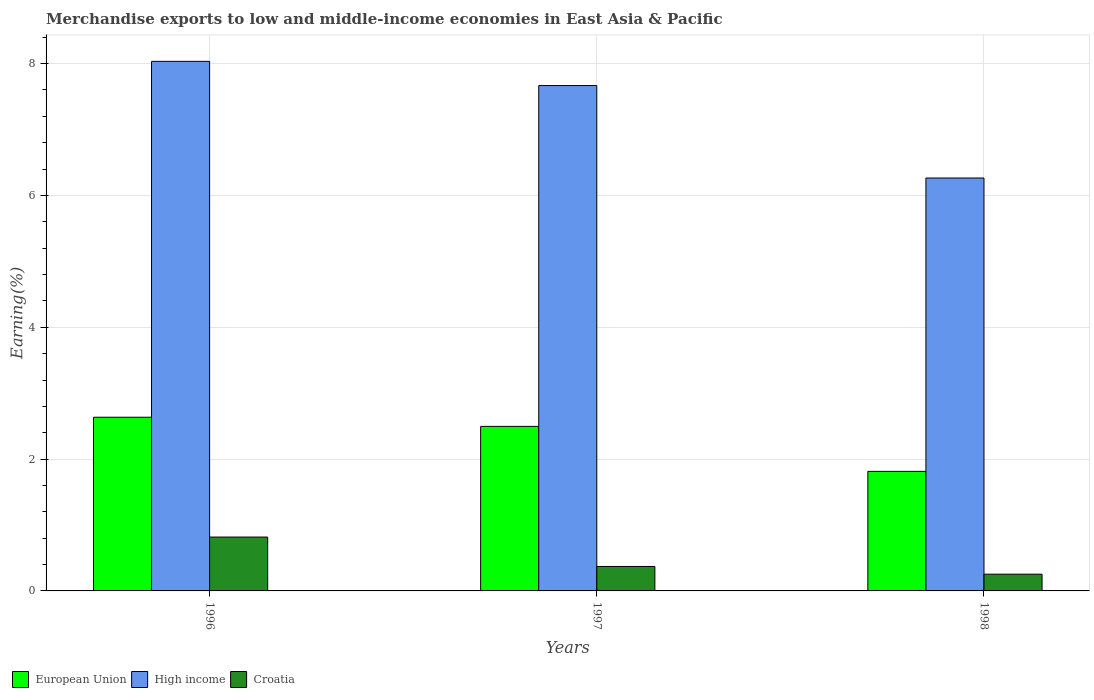How many different coloured bars are there?
Make the answer very short. 3. Are the number of bars on each tick of the X-axis equal?
Provide a short and direct response. Yes. How many bars are there on the 1st tick from the left?
Make the answer very short. 3. How many bars are there on the 3rd tick from the right?
Give a very brief answer. 3. What is the percentage of amount earned from merchandise exports in Croatia in 1996?
Make the answer very short. 0.82. Across all years, what is the maximum percentage of amount earned from merchandise exports in Croatia?
Give a very brief answer. 0.82. Across all years, what is the minimum percentage of amount earned from merchandise exports in Croatia?
Your answer should be compact. 0.25. What is the total percentage of amount earned from merchandise exports in European Union in the graph?
Keep it short and to the point. 6.95. What is the difference between the percentage of amount earned from merchandise exports in High income in 1997 and that in 1998?
Your answer should be compact. 1.4. What is the difference between the percentage of amount earned from merchandise exports in High income in 1997 and the percentage of amount earned from merchandise exports in European Union in 1996?
Your answer should be very brief. 5.03. What is the average percentage of amount earned from merchandise exports in High income per year?
Keep it short and to the point. 7.32. In the year 1996, what is the difference between the percentage of amount earned from merchandise exports in High income and percentage of amount earned from merchandise exports in Croatia?
Provide a short and direct response. 7.22. In how many years, is the percentage of amount earned from merchandise exports in High income greater than 3.2 %?
Keep it short and to the point. 3. What is the ratio of the percentage of amount earned from merchandise exports in High income in 1997 to that in 1998?
Your answer should be compact. 1.22. What is the difference between the highest and the second highest percentage of amount earned from merchandise exports in High income?
Offer a terse response. 0.37. What is the difference between the highest and the lowest percentage of amount earned from merchandise exports in Croatia?
Keep it short and to the point. 0.56. What does the 3rd bar from the left in 1996 represents?
Your answer should be compact. Croatia. What does the 2nd bar from the right in 1998 represents?
Offer a terse response. High income. Is it the case that in every year, the sum of the percentage of amount earned from merchandise exports in European Union and percentage of amount earned from merchandise exports in Croatia is greater than the percentage of amount earned from merchandise exports in High income?
Your answer should be very brief. No. Are all the bars in the graph horizontal?
Your answer should be very brief. No. Where does the legend appear in the graph?
Your answer should be compact. Bottom left. How many legend labels are there?
Your answer should be compact. 3. How are the legend labels stacked?
Offer a terse response. Horizontal. What is the title of the graph?
Give a very brief answer. Merchandise exports to low and middle-income economies in East Asia & Pacific. Does "Turks and Caicos Islands" appear as one of the legend labels in the graph?
Provide a succinct answer. No. What is the label or title of the X-axis?
Offer a very short reply. Years. What is the label or title of the Y-axis?
Offer a very short reply. Earning(%). What is the Earning(%) of European Union in 1996?
Offer a terse response. 2.64. What is the Earning(%) of High income in 1996?
Your response must be concise. 8.03. What is the Earning(%) in Croatia in 1996?
Your answer should be compact. 0.82. What is the Earning(%) of European Union in 1997?
Offer a very short reply. 2.5. What is the Earning(%) of High income in 1997?
Make the answer very short. 7.67. What is the Earning(%) of Croatia in 1997?
Offer a terse response. 0.37. What is the Earning(%) in European Union in 1998?
Provide a succinct answer. 1.81. What is the Earning(%) in High income in 1998?
Offer a terse response. 6.26. What is the Earning(%) of Croatia in 1998?
Make the answer very short. 0.25. Across all years, what is the maximum Earning(%) in European Union?
Offer a terse response. 2.64. Across all years, what is the maximum Earning(%) in High income?
Make the answer very short. 8.03. Across all years, what is the maximum Earning(%) of Croatia?
Your response must be concise. 0.82. Across all years, what is the minimum Earning(%) of European Union?
Offer a very short reply. 1.81. Across all years, what is the minimum Earning(%) of High income?
Provide a succinct answer. 6.26. Across all years, what is the minimum Earning(%) in Croatia?
Provide a short and direct response. 0.25. What is the total Earning(%) in European Union in the graph?
Give a very brief answer. 6.95. What is the total Earning(%) in High income in the graph?
Ensure brevity in your answer.  21.97. What is the total Earning(%) in Croatia in the graph?
Offer a very short reply. 1.44. What is the difference between the Earning(%) of European Union in 1996 and that in 1997?
Give a very brief answer. 0.14. What is the difference between the Earning(%) of High income in 1996 and that in 1997?
Provide a short and direct response. 0.37. What is the difference between the Earning(%) of Croatia in 1996 and that in 1997?
Offer a very short reply. 0.45. What is the difference between the Earning(%) of European Union in 1996 and that in 1998?
Offer a terse response. 0.82. What is the difference between the Earning(%) of High income in 1996 and that in 1998?
Your response must be concise. 1.77. What is the difference between the Earning(%) in Croatia in 1996 and that in 1998?
Offer a terse response. 0.56. What is the difference between the Earning(%) in European Union in 1997 and that in 1998?
Your response must be concise. 0.68. What is the difference between the Earning(%) of High income in 1997 and that in 1998?
Ensure brevity in your answer.  1.4. What is the difference between the Earning(%) in Croatia in 1997 and that in 1998?
Your response must be concise. 0.12. What is the difference between the Earning(%) in European Union in 1996 and the Earning(%) in High income in 1997?
Offer a terse response. -5.03. What is the difference between the Earning(%) in European Union in 1996 and the Earning(%) in Croatia in 1997?
Provide a short and direct response. 2.26. What is the difference between the Earning(%) in High income in 1996 and the Earning(%) in Croatia in 1997?
Provide a succinct answer. 7.66. What is the difference between the Earning(%) in European Union in 1996 and the Earning(%) in High income in 1998?
Offer a terse response. -3.63. What is the difference between the Earning(%) of European Union in 1996 and the Earning(%) of Croatia in 1998?
Provide a short and direct response. 2.38. What is the difference between the Earning(%) of High income in 1996 and the Earning(%) of Croatia in 1998?
Offer a very short reply. 7.78. What is the difference between the Earning(%) of European Union in 1997 and the Earning(%) of High income in 1998?
Provide a succinct answer. -3.77. What is the difference between the Earning(%) in European Union in 1997 and the Earning(%) in Croatia in 1998?
Provide a short and direct response. 2.24. What is the difference between the Earning(%) of High income in 1997 and the Earning(%) of Croatia in 1998?
Ensure brevity in your answer.  7.41. What is the average Earning(%) of European Union per year?
Give a very brief answer. 2.32. What is the average Earning(%) of High income per year?
Give a very brief answer. 7.32. What is the average Earning(%) in Croatia per year?
Make the answer very short. 0.48. In the year 1996, what is the difference between the Earning(%) of European Union and Earning(%) of High income?
Ensure brevity in your answer.  -5.4. In the year 1996, what is the difference between the Earning(%) in European Union and Earning(%) in Croatia?
Make the answer very short. 1.82. In the year 1996, what is the difference between the Earning(%) in High income and Earning(%) in Croatia?
Your answer should be very brief. 7.22. In the year 1997, what is the difference between the Earning(%) in European Union and Earning(%) in High income?
Ensure brevity in your answer.  -5.17. In the year 1997, what is the difference between the Earning(%) in European Union and Earning(%) in Croatia?
Ensure brevity in your answer.  2.13. In the year 1997, what is the difference between the Earning(%) of High income and Earning(%) of Croatia?
Offer a terse response. 7.3. In the year 1998, what is the difference between the Earning(%) in European Union and Earning(%) in High income?
Your answer should be compact. -4.45. In the year 1998, what is the difference between the Earning(%) of European Union and Earning(%) of Croatia?
Your answer should be compact. 1.56. In the year 1998, what is the difference between the Earning(%) in High income and Earning(%) in Croatia?
Your answer should be compact. 6.01. What is the ratio of the Earning(%) in European Union in 1996 to that in 1997?
Offer a terse response. 1.06. What is the ratio of the Earning(%) in High income in 1996 to that in 1997?
Ensure brevity in your answer.  1.05. What is the ratio of the Earning(%) in Croatia in 1996 to that in 1997?
Your response must be concise. 2.2. What is the ratio of the Earning(%) in European Union in 1996 to that in 1998?
Keep it short and to the point. 1.45. What is the ratio of the Earning(%) of High income in 1996 to that in 1998?
Make the answer very short. 1.28. What is the ratio of the Earning(%) in Croatia in 1996 to that in 1998?
Keep it short and to the point. 3.22. What is the ratio of the Earning(%) in European Union in 1997 to that in 1998?
Ensure brevity in your answer.  1.38. What is the ratio of the Earning(%) of High income in 1997 to that in 1998?
Make the answer very short. 1.22. What is the ratio of the Earning(%) of Croatia in 1997 to that in 1998?
Offer a terse response. 1.46. What is the difference between the highest and the second highest Earning(%) in European Union?
Your response must be concise. 0.14. What is the difference between the highest and the second highest Earning(%) in High income?
Your response must be concise. 0.37. What is the difference between the highest and the second highest Earning(%) of Croatia?
Ensure brevity in your answer.  0.45. What is the difference between the highest and the lowest Earning(%) of European Union?
Your response must be concise. 0.82. What is the difference between the highest and the lowest Earning(%) in High income?
Give a very brief answer. 1.77. What is the difference between the highest and the lowest Earning(%) in Croatia?
Your answer should be compact. 0.56. 